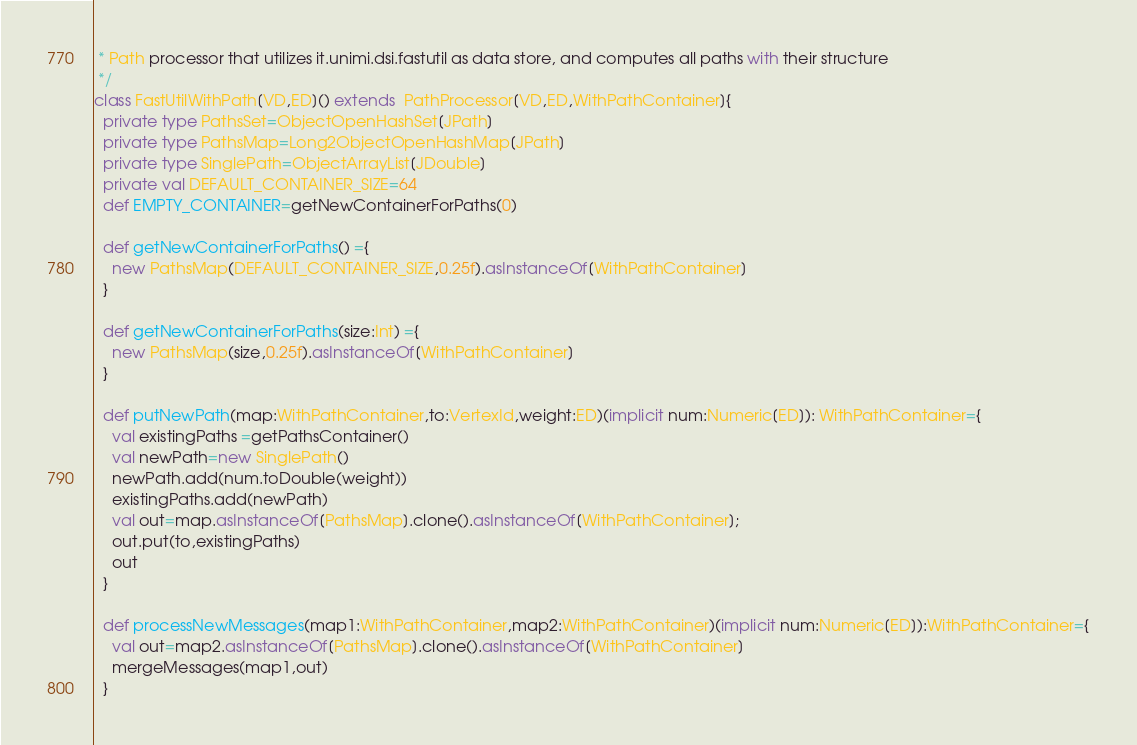<code> <loc_0><loc_0><loc_500><loc_500><_Scala_> * Path processor that utilizes it.unimi.dsi.fastutil as data store, and computes all paths with their structure
 */
class FastUtilWithPath[VD,ED]() extends  PathProcessor[VD,ED,WithPathContainer]{
  private type PathsSet=ObjectOpenHashSet[JPath]
  private type PathsMap=Long2ObjectOpenHashMap[JPath]
  private type SinglePath=ObjectArrayList[JDouble]
  private val DEFAULT_CONTAINER_SIZE=64
  def EMPTY_CONTAINER=getNewContainerForPaths(0)

  def getNewContainerForPaths() ={
    new PathsMap(DEFAULT_CONTAINER_SIZE,0.25f).asInstanceOf[WithPathContainer]
  }

  def getNewContainerForPaths(size:Int) ={
    new PathsMap(size,0.25f).asInstanceOf[WithPathContainer]
  }

  def putNewPath(map:WithPathContainer,to:VertexId,weight:ED)(implicit num:Numeric[ED]): WithPathContainer={
    val existingPaths =getPathsContainer()
    val newPath=new SinglePath()
    newPath.add(num.toDouble(weight))
    existingPaths.add(newPath)
    val out=map.asInstanceOf[PathsMap].clone().asInstanceOf[WithPathContainer];
    out.put(to,existingPaths)
    out
  }

  def processNewMessages(map1:WithPathContainer,map2:WithPathContainer)(implicit num:Numeric[ED]):WithPathContainer={
    val out=map2.asInstanceOf[PathsMap].clone().asInstanceOf[WithPathContainer]
    mergeMessages(map1,out)
  }
</code> 